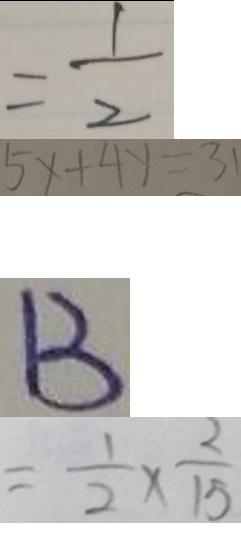Convert formula to latex. <formula><loc_0><loc_0><loc_500><loc_500>= \frac { 1 } { 2 } 
 5 x + 4 y = 3 1 
 B 
 = \frac { 1 } { 2 } \times \frac { 2 } { 1 5 }</formula> 